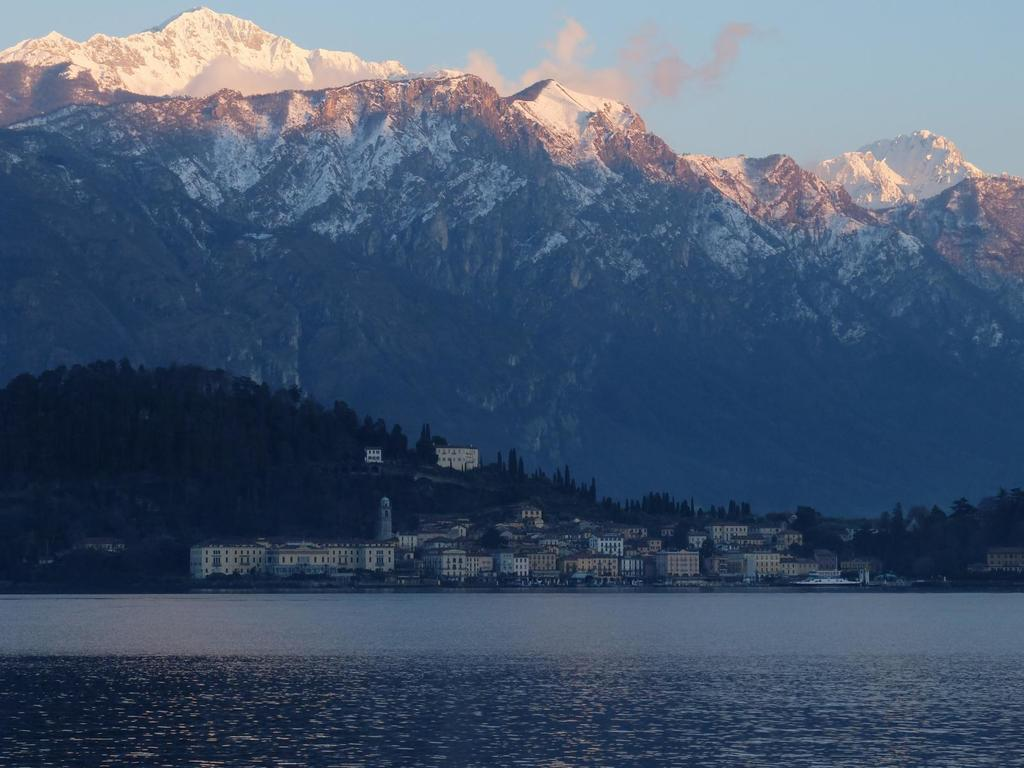What is the primary element visible in the image? There is water in the image. What type of structures can be seen in the image? There are buildings in the image. What type of vegetation is present in the image? There are trees in the image. What geographical feature can be seen in the background of the image? There are mountains in the background of the image. What is visible at the top of the image? The sky is visible at the top of the image. Can you tell me what book the representative is holding in the image? There is no representative or book present in the image. 